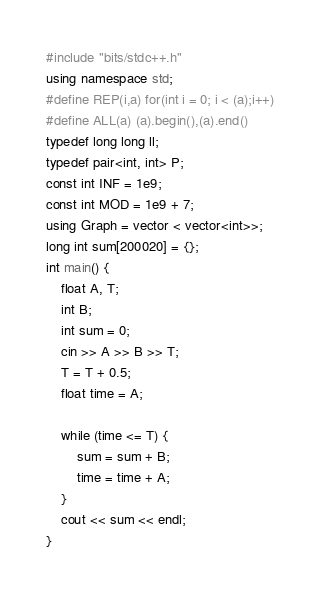<code> <loc_0><loc_0><loc_500><loc_500><_C++_>#include "bits/stdc++.h"
using namespace std;
#define REP(i,a) for(int i = 0; i < (a);i++)
#define ALL(a) (a).begin(),(a).end()
typedef long long ll;
typedef pair<int, int> P;
const int INF = 1e9;
const int MOD = 1e9 + 7;
using Graph = vector < vector<int>>;
long int sum[200020] = {};
int main() {
	float A, T;
	int B;
	int sum = 0;
	cin >> A >> B >> T;
	T = T + 0.5;
	float time = A;

	while (time <= T) {
		sum = sum + B;
		time = time + A;
	}
	cout << sum << endl;
}</code> 